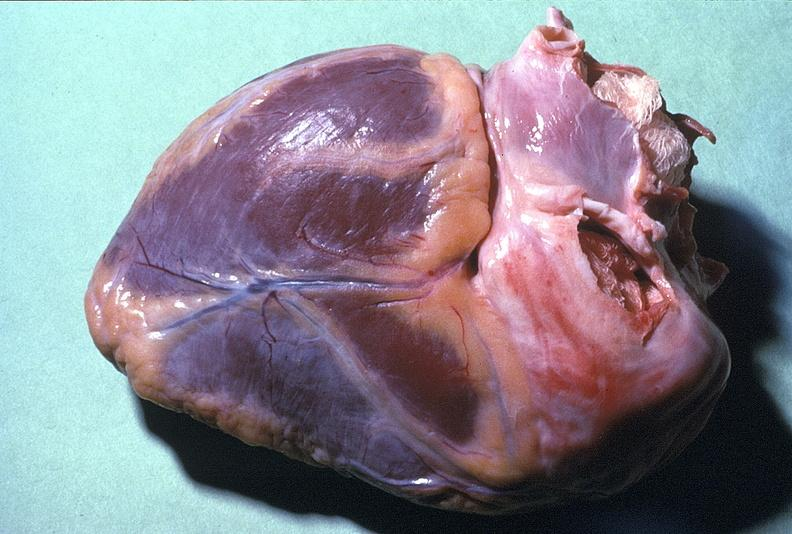what does this image show?
Answer the question using a single word or phrase. Normal duct in postmenopausal woman 